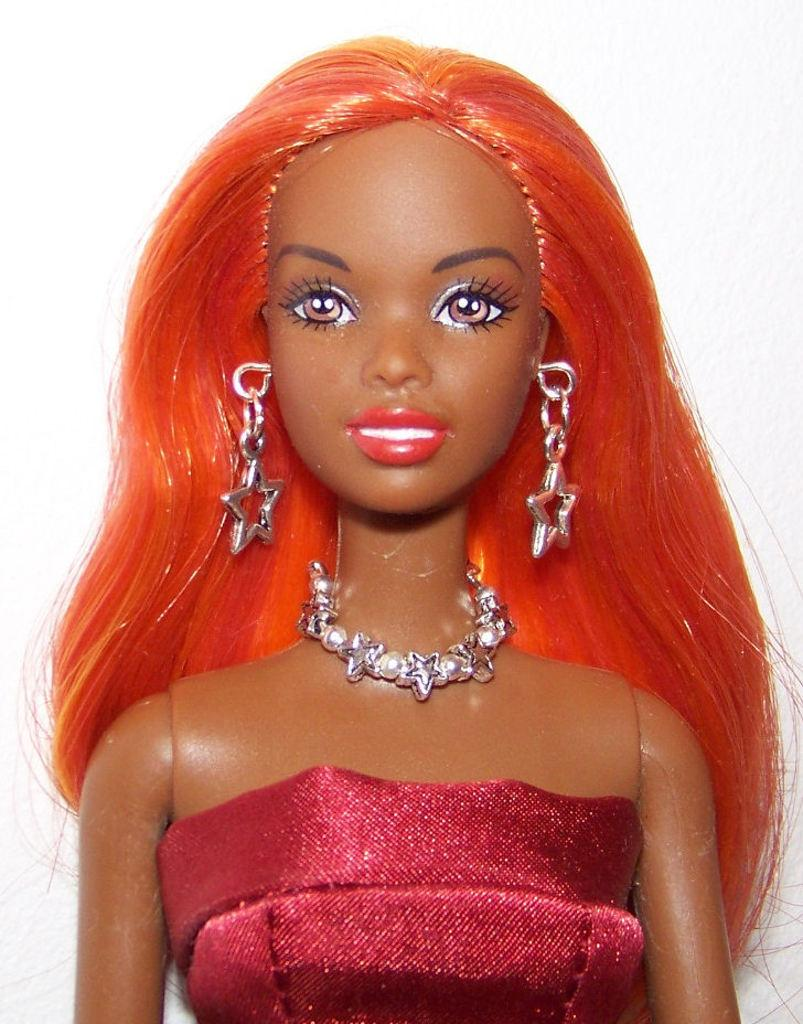What is the main subject of the image? There is a doll in the image. Is the doll stuck in quicksand in the image? There is no quicksand present in the image, and therefore the doll is not stuck in it. Does the doll have a friend in the image? The provided facts do not mention any other subjects or objects in the image, so it cannot be determined if the doll has a friend. 